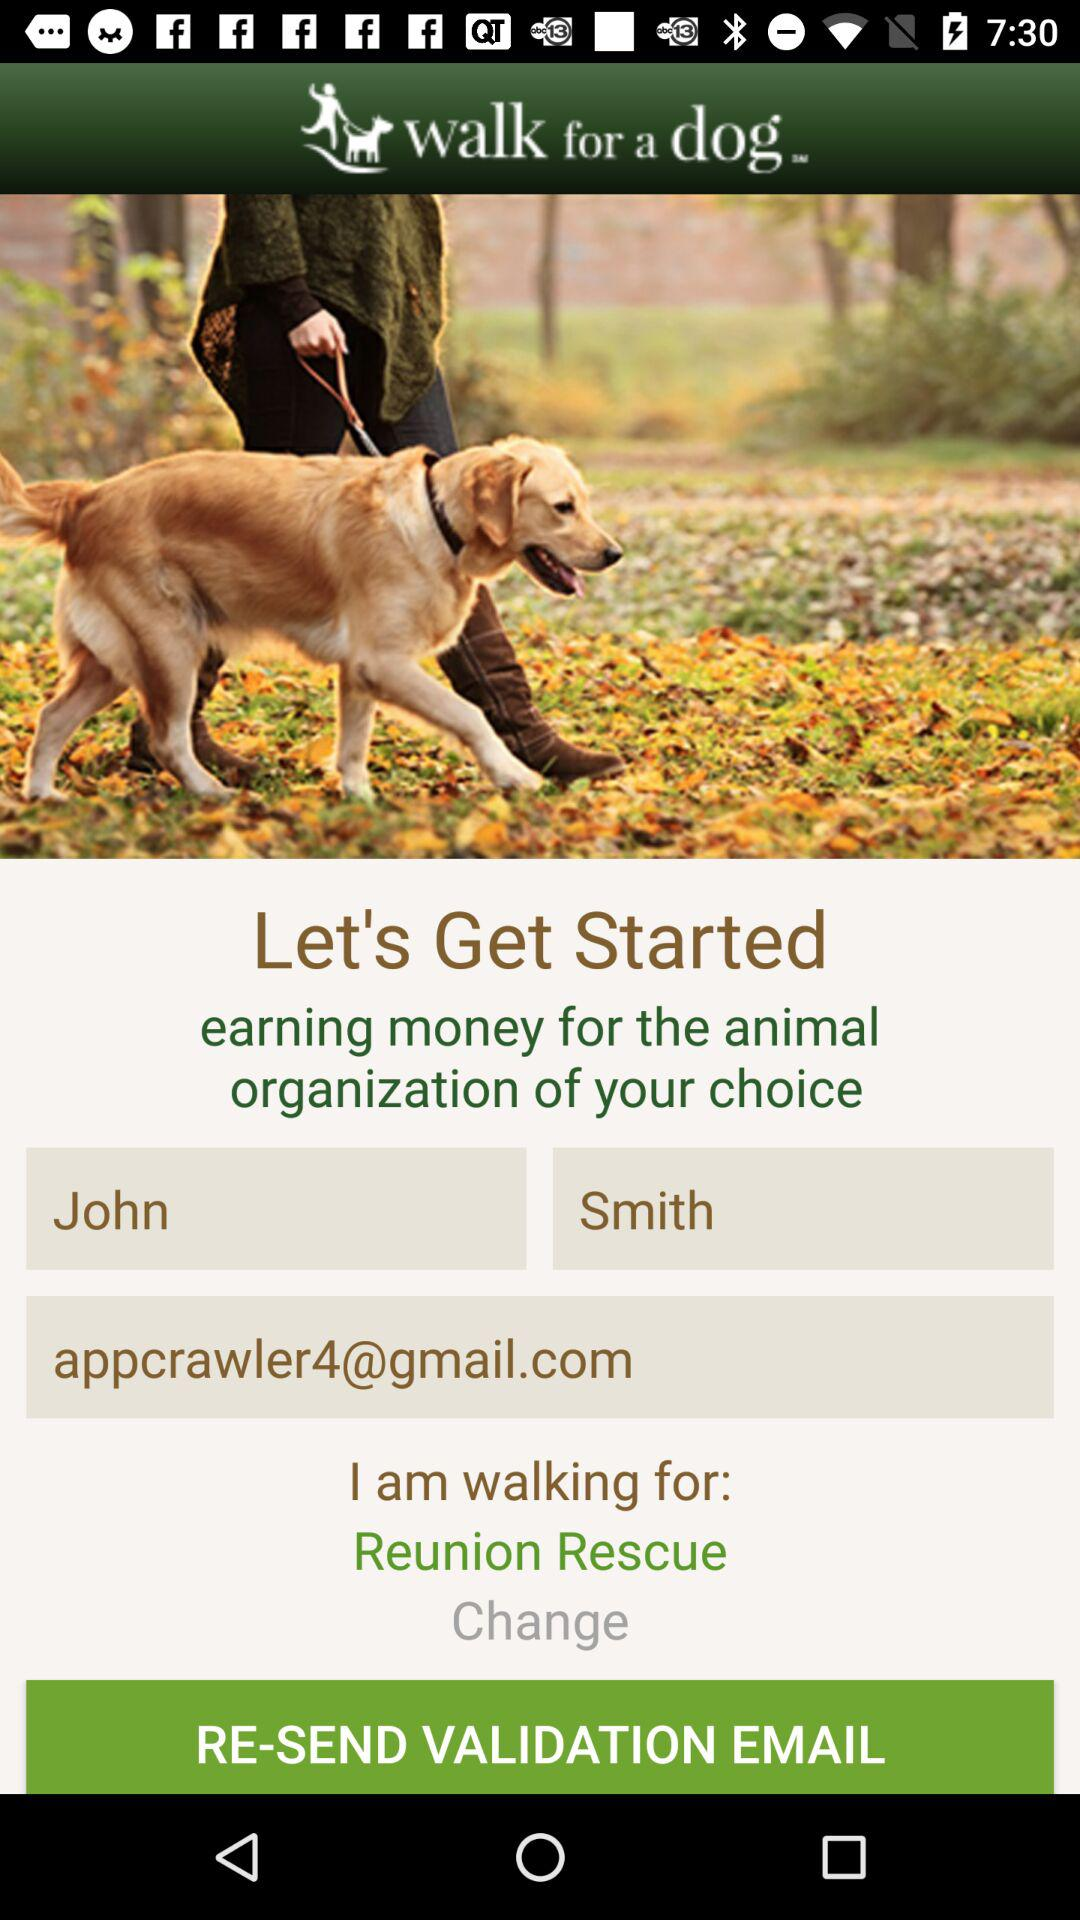How many text inputs are there for the user to fill out?
Answer the question using a single word or phrase. 3 